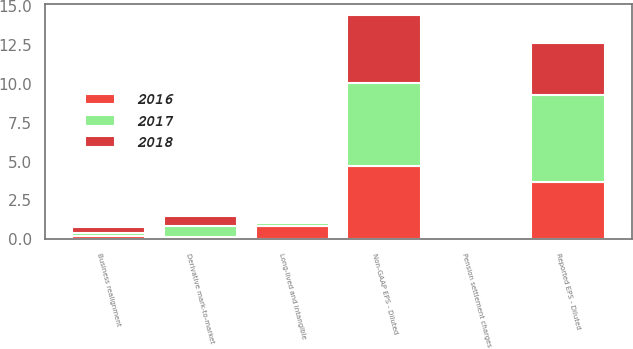Convert chart. <chart><loc_0><loc_0><loc_500><loc_500><stacked_bar_chart><ecel><fcel>Reported EPS - Diluted<fcel>Derivative mark-to-market<fcel>Business realignment<fcel>Pension settlement charges<fcel>Long-lived and intangible<fcel>Non-GAAP EPS - Diluted<nl><fcel>2017<fcel>5.58<fcel>0.72<fcel>0.18<fcel>0.02<fcel>0.2<fcel>5.36<nl><fcel>2016<fcel>3.66<fcel>0.14<fcel>0.25<fcel>0.02<fcel>0.87<fcel>4.69<nl><fcel>2018<fcel>3.34<fcel>0.66<fcel>0.38<fcel>0.04<fcel>0.01<fcel>4.33<nl></chart> 